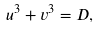Convert formula to latex. <formula><loc_0><loc_0><loc_500><loc_500>u ^ { 3 } + v ^ { 3 } = D ,</formula> 